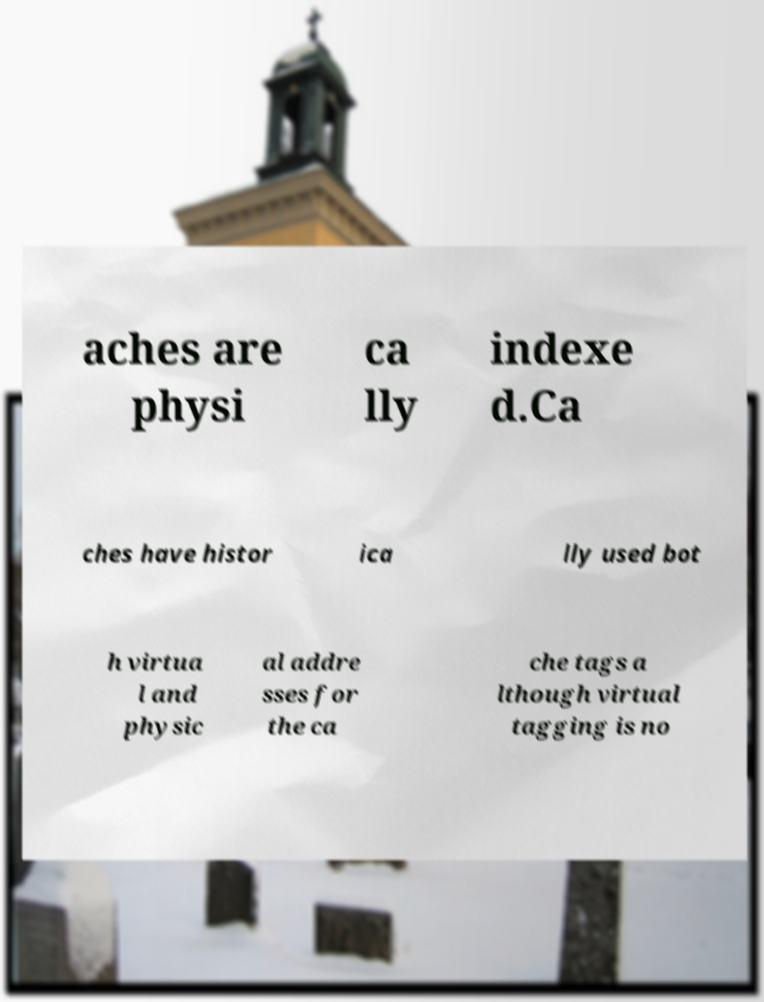Could you extract and type out the text from this image? aches are physi ca lly indexe d.Ca ches have histor ica lly used bot h virtua l and physic al addre sses for the ca che tags a lthough virtual tagging is no 